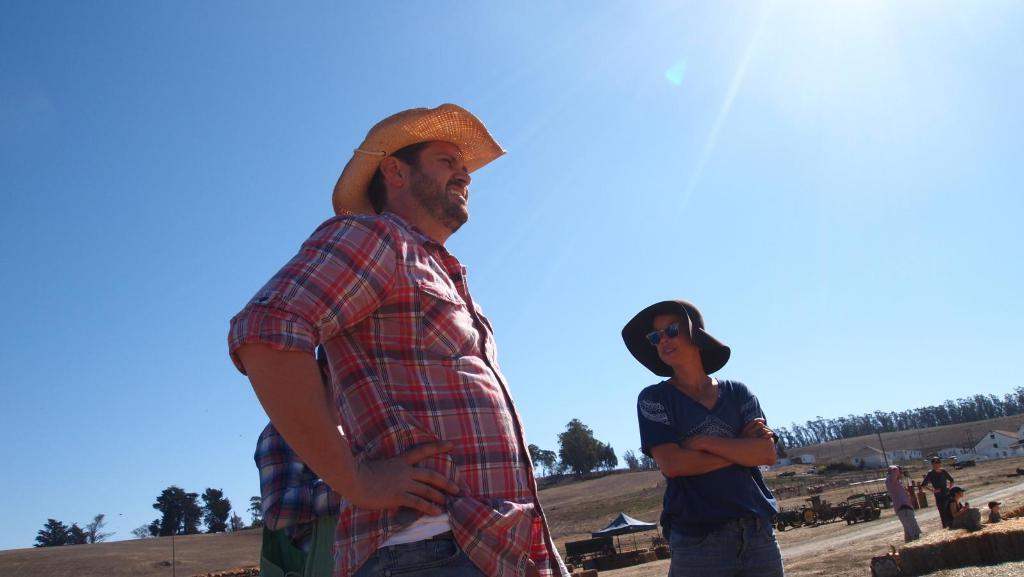Can you describe this image briefly? In this picture there is a man who is wearing t-shirt and jeans, beside him there is a woman who is wearing t-shirt and trouser. Behind there is another person who is wearing shirt. On the right I can see some persons who are standing and sitting near to the road. In the back I can see the tent, bikes and other objects. In the background I can see the mountain and trees. At the top I can see the sky and sun's light beam. 